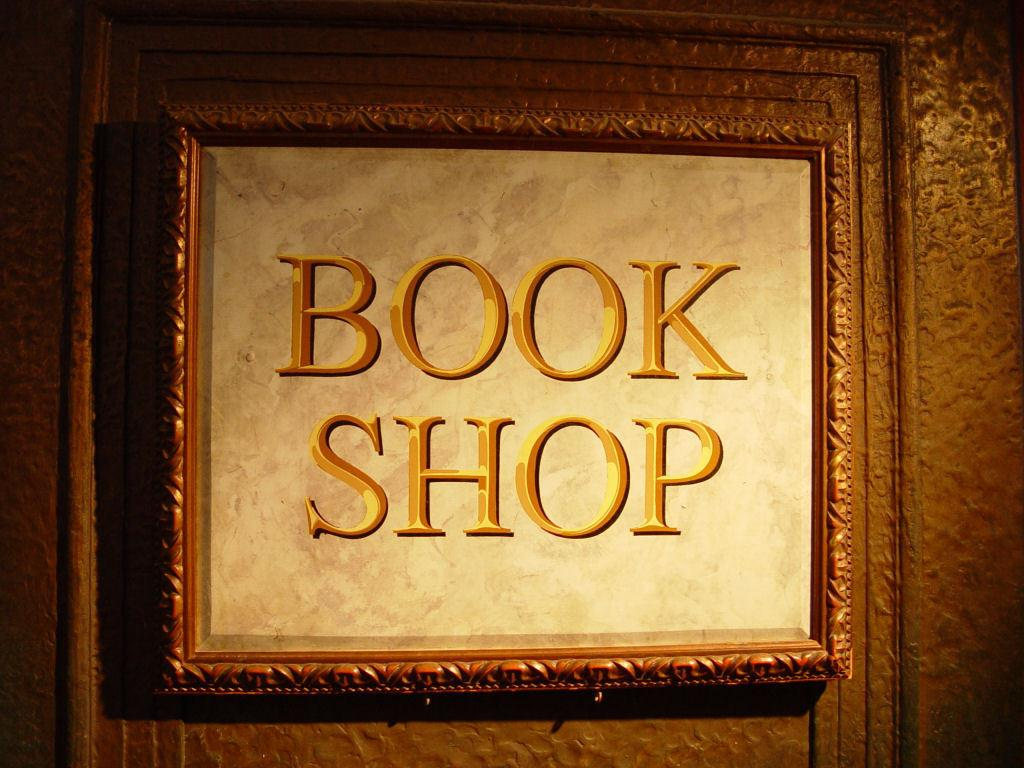<image>
Render a clear and concise summary of the photo. Sign in a frame with words that say BOOK SHOP. 